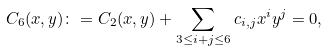<formula> <loc_0><loc_0><loc_500><loc_500>C _ { 6 } ( x , y ) \colon = C _ { 2 } ( x , y ) + \sum _ { 3 \leq i + j \leq 6 } c _ { i , j } x ^ { i } y ^ { j } = 0 ,</formula> 